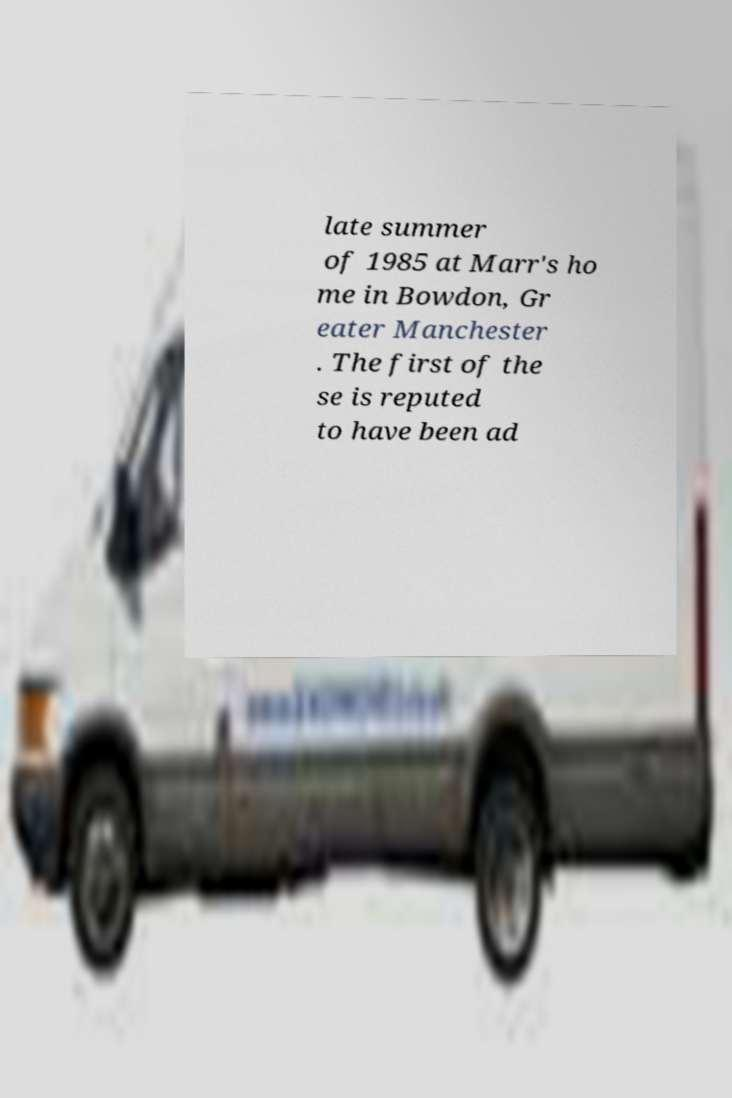What messages or text are displayed in this image? I need them in a readable, typed format. late summer of 1985 at Marr's ho me in Bowdon, Gr eater Manchester . The first of the se is reputed to have been ad 